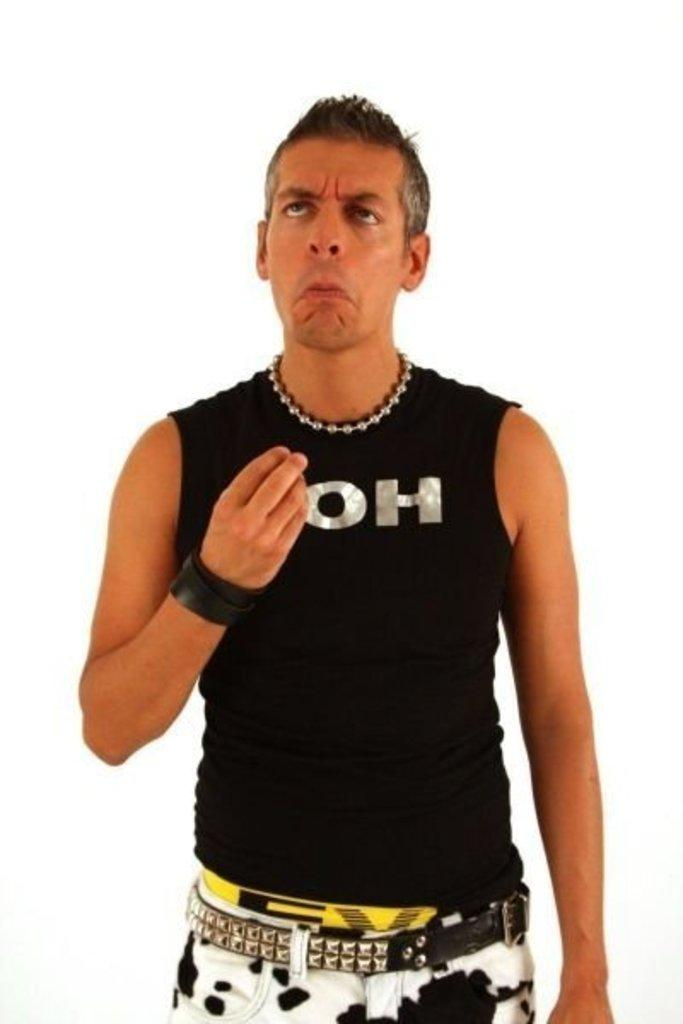<image>
Relay a brief, clear account of the picture shown. guy with wierd expression on his face wearing black tank top ith letter OH on it 